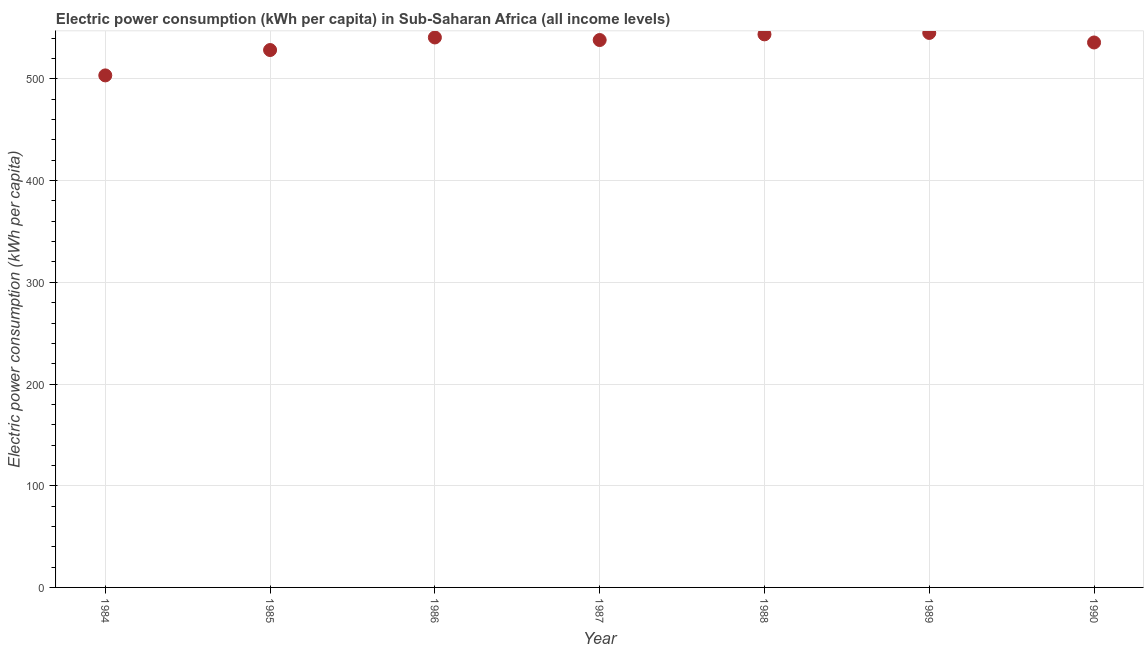What is the electric power consumption in 1985?
Make the answer very short. 528.41. Across all years, what is the maximum electric power consumption?
Ensure brevity in your answer.  545.21. Across all years, what is the minimum electric power consumption?
Your response must be concise. 503.46. What is the sum of the electric power consumption?
Your response must be concise. 3735.72. What is the difference between the electric power consumption in 1986 and 1989?
Your answer should be very brief. -4.44. What is the average electric power consumption per year?
Make the answer very short. 533.67. What is the median electric power consumption?
Your answer should be compact. 538.24. Do a majority of the years between 1990 and 1985 (inclusive) have electric power consumption greater than 460 kWh per capita?
Offer a very short reply. Yes. What is the ratio of the electric power consumption in 1988 to that in 1990?
Provide a short and direct response. 1.01. Is the difference between the electric power consumption in 1989 and 1990 greater than the difference between any two years?
Your response must be concise. No. What is the difference between the highest and the second highest electric power consumption?
Provide a succinct answer. 1.4. Is the sum of the electric power consumption in 1985 and 1990 greater than the maximum electric power consumption across all years?
Keep it short and to the point. Yes. What is the difference between the highest and the lowest electric power consumption?
Offer a very short reply. 41.75. Does the electric power consumption monotonically increase over the years?
Offer a terse response. No. How many dotlines are there?
Your answer should be very brief. 1. How many years are there in the graph?
Your response must be concise. 7. What is the title of the graph?
Your answer should be compact. Electric power consumption (kWh per capita) in Sub-Saharan Africa (all income levels). What is the label or title of the X-axis?
Offer a very short reply. Year. What is the label or title of the Y-axis?
Provide a succinct answer. Electric power consumption (kWh per capita). What is the Electric power consumption (kWh per capita) in 1984?
Make the answer very short. 503.46. What is the Electric power consumption (kWh per capita) in 1985?
Offer a very short reply. 528.41. What is the Electric power consumption (kWh per capita) in 1986?
Keep it short and to the point. 540.77. What is the Electric power consumption (kWh per capita) in 1987?
Provide a short and direct response. 538.24. What is the Electric power consumption (kWh per capita) in 1988?
Offer a terse response. 543.81. What is the Electric power consumption (kWh per capita) in 1989?
Your response must be concise. 545.21. What is the Electric power consumption (kWh per capita) in 1990?
Offer a terse response. 535.83. What is the difference between the Electric power consumption (kWh per capita) in 1984 and 1985?
Your response must be concise. -24.95. What is the difference between the Electric power consumption (kWh per capita) in 1984 and 1986?
Provide a short and direct response. -37.31. What is the difference between the Electric power consumption (kWh per capita) in 1984 and 1987?
Provide a succinct answer. -34.78. What is the difference between the Electric power consumption (kWh per capita) in 1984 and 1988?
Provide a succinct answer. -40.35. What is the difference between the Electric power consumption (kWh per capita) in 1984 and 1989?
Offer a terse response. -41.75. What is the difference between the Electric power consumption (kWh per capita) in 1984 and 1990?
Ensure brevity in your answer.  -32.37. What is the difference between the Electric power consumption (kWh per capita) in 1985 and 1986?
Your answer should be very brief. -12.36. What is the difference between the Electric power consumption (kWh per capita) in 1985 and 1987?
Your answer should be compact. -9.84. What is the difference between the Electric power consumption (kWh per capita) in 1985 and 1988?
Provide a succinct answer. -15.4. What is the difference between the Electric power consumption (kWh per capita) in 1985 and 1989?
Ensure brevity in your answer.  -16.8. What is the difference between the Electric power consumption (kWh per capita) in 1985 and 1990?
Your answer should be very brief. -7.43. What is the difference between the Electric power consumption (kWh per capita) in 1986 and 1987?
Your answer should be very brief. 2.52. What is the difference between the Electric power consumption (kWh per capita) in 1986 and 1988?
Provide a short and direct response. -3.04. What is the difference between the Electric power consumption (kWh per capita) in 1986 and 1989?
Give a very brief answer. -4.44. What is the difference between the Electric power consumption (kWh per capita) in 1986 and 1990?
Keep it short and to the point. 4.93. What is the difference between the Electric power consumption (kWh per capita) in 1987 and 1988?
Offer a very short reply. -5.57. What is the difference between the Electric power consumption (kWh per capita) in 1987 and 1989?
Provide a succinct answer. -6.96. What is the difference between the Electric power consumption (kWh per capita) in 1987 and 1990?
Keep it short and to the point. 2.41. What is the difference between the Electric power consumption (kWh per capita) in 1988 and 1989?
Offer a very short reply. -1.4. What is the difference between the Electric power consumption (kWh per capita) in 1988 and 1990?
Your answer should be very brief. 7.98. What is the difference between the Electric power consumption (kWh per capita) in 1989 and 1990?
Make the answer very short. 9.37. What is the ratio of the Electric power consumption (kWh per capita) in 1984 to that in 1985?
Offer a very short reply. 0.95. What is the ratio of the Electric power consumption (kWh per capita) in 1984 to that in 1986?
Keep it short and to the point. 0.93. What is the ratio of the Electric power consumption (kWh per capita) in 1984 to that in 1987?
Provide a short and direct response. 0.94. What is the ratio of the Electric power consumption (kWh per capita) in 1984 to that in 1988?
Your answer should be compact. 0.93. What is the ratio of the Electric power consumption (kWh per capita) in 1984 to that in 1989?
Give a very brief answer. 0.92. What is the ratio of the Electric power consumption (kWh per capita) in 1985 to that in 1988?
Your answer should be very brief. 0.97. What is the ratio of the Electric power consumption (kWh per capita) in 1986 to that in 1987?
Offer a very short reply. 1. What is the ratio of the Electric power consumption (kWh per capita) in 1986 to that in 1988?
Your response must be concise. 0.99. What is the ratio of the Electric power consumption (kWh per capita) in 1986 to that in 1989?
Provide a short and direct response. 0.99. What is the ratio of the Electric power consumption (kWh per capita) in 1987 to that in 1989?
Provide a succinct answer. 0.99. What is the ratio of the Electric power consumption (kWh per capita) in 1987 to that in 1990?
Offer a terse response. 1. What is the ratio of the Electric power consumption (kWh per capita) in 1988 to that in 1989?
Ensure brevity in your answer.  1. What is the ratio of the Electric power consumption (kWh per capita) in 1988 to that in 1990?
Make the answer very short. 1.01. What is the ratio of the Electric power consumption (kWh per capita) in 1989 to that in 1990?
Make the answer very short. 1.02. 